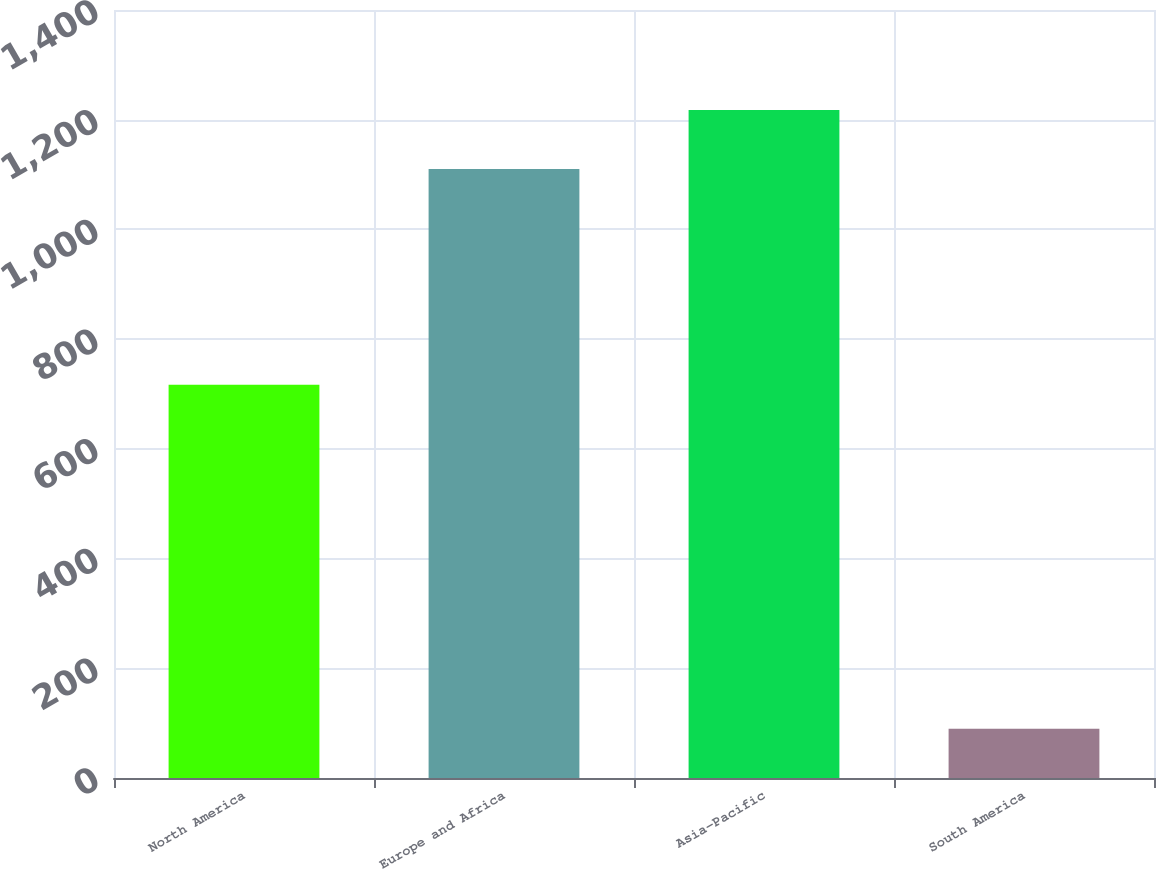Convert chart. <chart><loc_0><loc_0><loc_500><loc_500><bar_chart><fcel>North America<fcel>Europe and Africa<fcel>Asia-Pacific<fcel>South America<nl><fcel>717<fcel>1110<fcel>1217.6<fcel>90<nl></chart> 